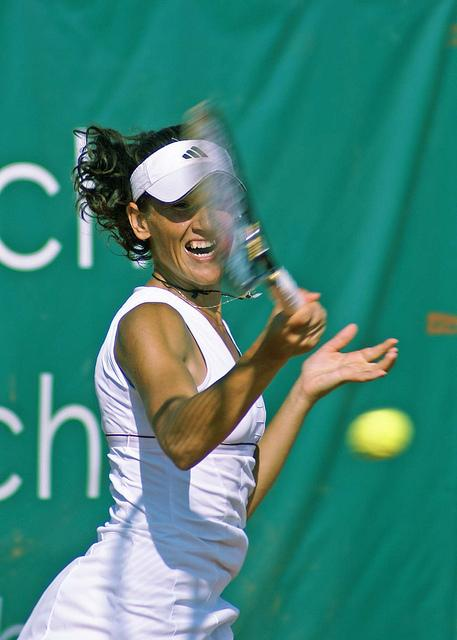Why is the racquet blurred? motion 